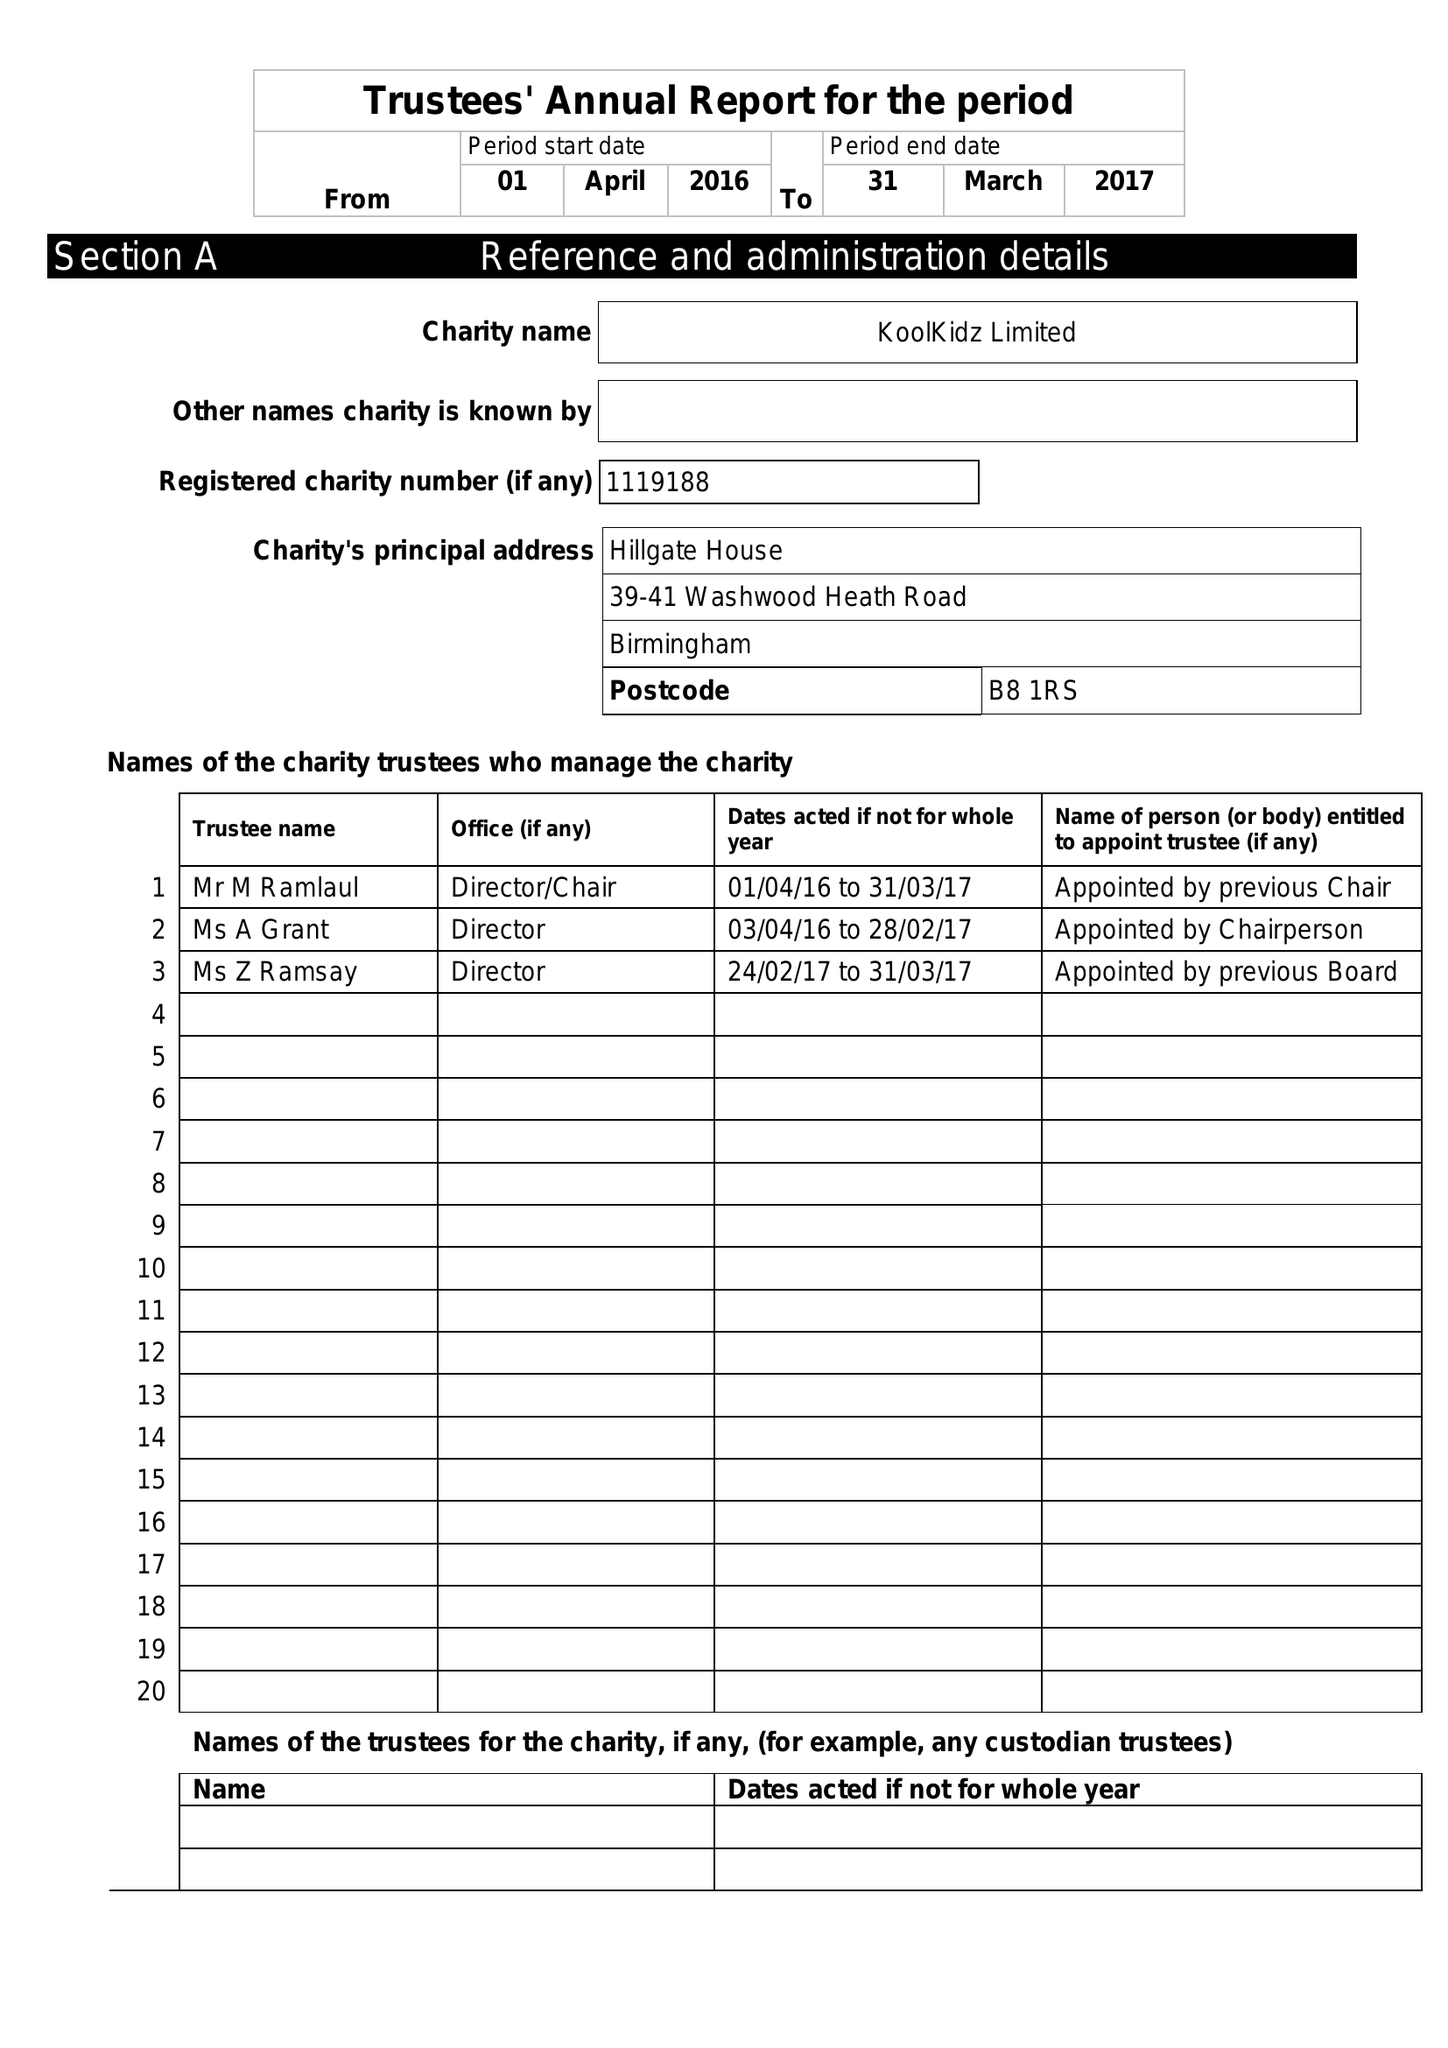What is the value for the charity_name?
Answer the question using a single word or phrase. Koolkidz Ltd. 